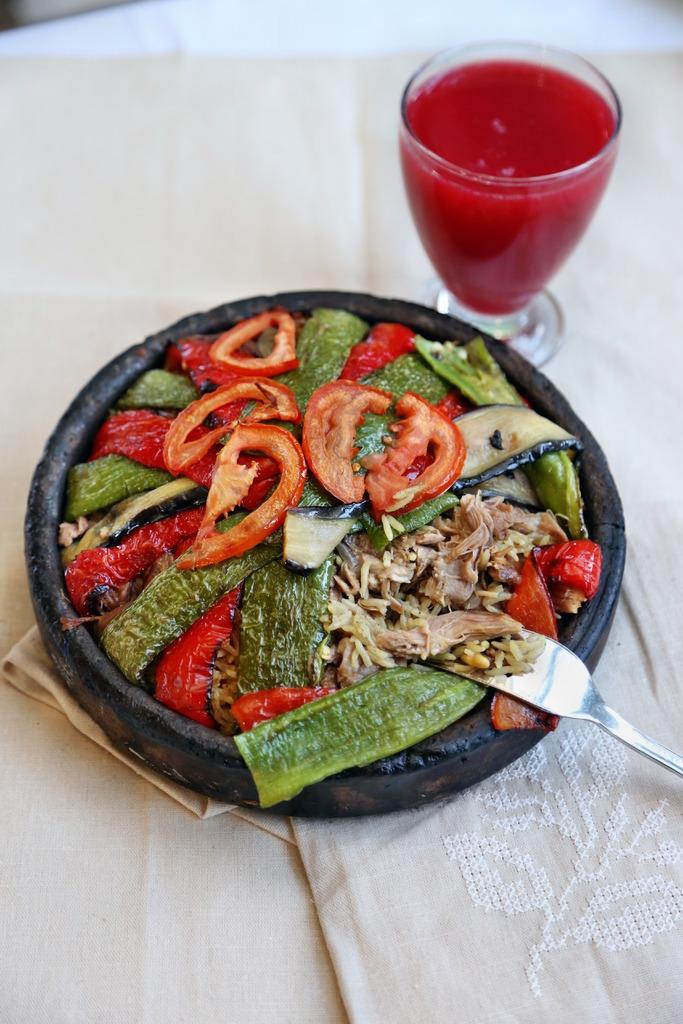What is on the plate in the image? There is a plate with salad in the image. What type of vegetables are included in the salad? The salad includes tomatoes and other vegetables. What utensil is used with the salad? There is a fork in the salad. What type of beverage is on the table? There is a glass of fruit juice on a table. How many grandfathers are sitting at the desk in the image? There is no desk or grandfather present in the image. 